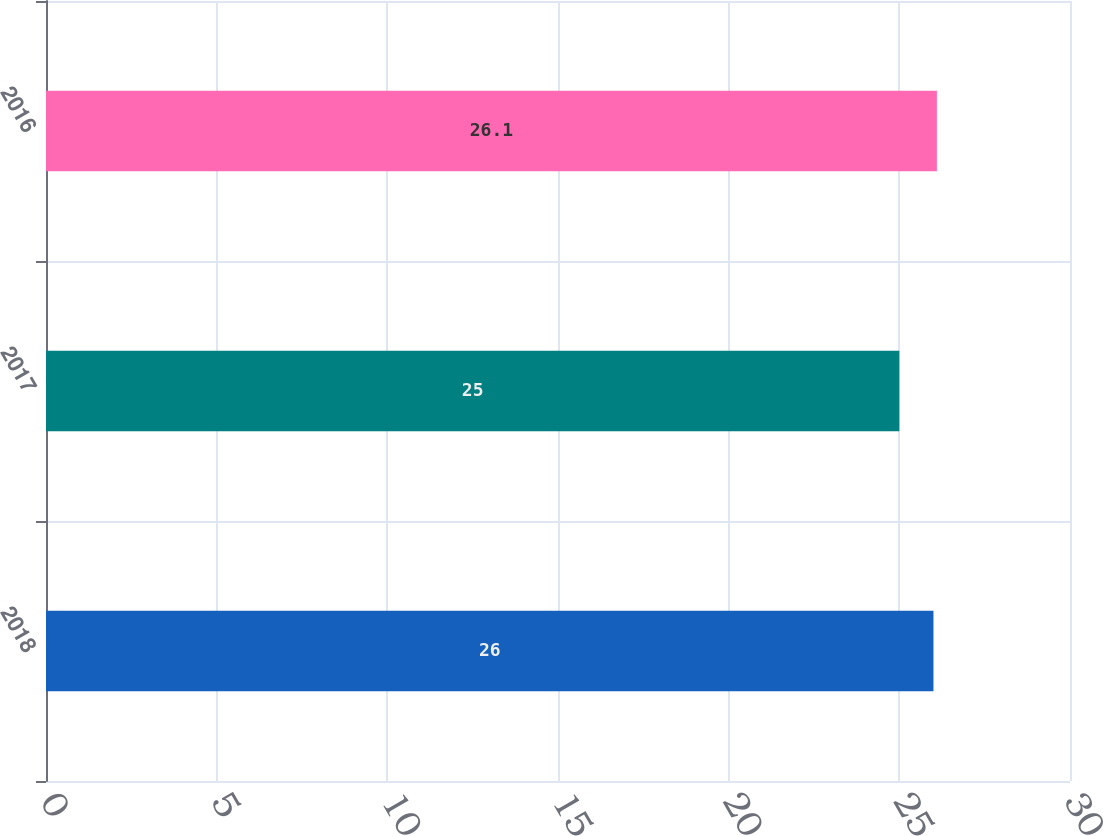Convert chart. <chart><loc_0><loc_0><loc_500><loc_500><bar_chart><fcel>2018<fcel>2017<fcel>2016<nl><fcel>26<fcel>25<fcel>26.1<nl></chart> 